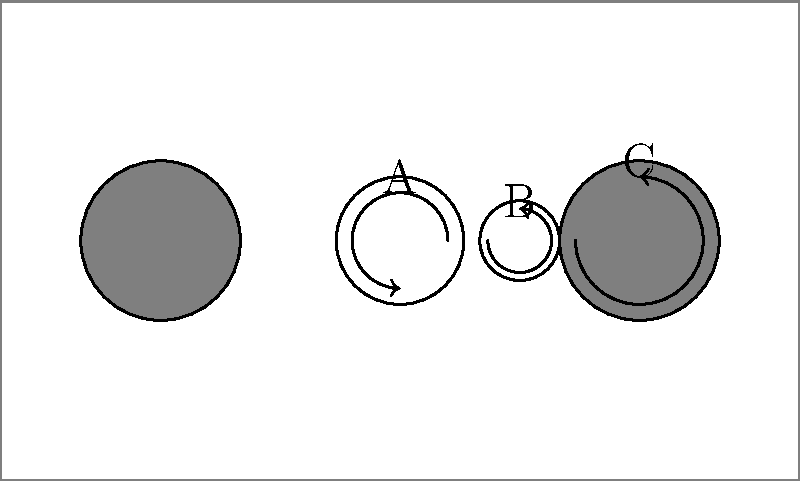In a manual film camera, gear A (radius 0.8 cm) is connected to the film advance lever. It meshes with gear B (radius 0.5 cm), which is attached to the take-up spool C (radius 1 cm). If the film advance lever rotates gear A by 270°, how many centimeters of film are wound onto the take-up spool? Let's approach this step-by-step:

1) First, we need to find how much gear B rotates when gear A rotates 270°.
   The rotation ratio is inversely proportional to the gear radii:
   $\frac{\text{Rotation of B}}{\text{Rotation of A}} = \frac{\text{Radius of A}}{\text{Radius of B}}$

2) So, $\text{Rotation of B} = 270° \times \frac{0.8 \text{ cm}}{0.5 \text{ cm}} = 432°$

3) Now, we need to find how much the take-up spool C rotates.
   Since B and C are attached, they rotate the same amount: 432°

4) To find the length of film wound, we need to calculate the arc length on the circumference of C:
   $\text{Arc length} = \text{Radius} \times \text{Angle in radians}$

5) First, convert 432° to radians:
   $432° \times \frac{\pi}{180°} = 2.4\pi \text{ radians}$

6) Now calculate the arc length:
   $\text{Arc length} = 1 \text{ cm} \times 2.4\pi \text{ radians} = 2.4\pi \text{ cm}$

Therefore, $2.4\pi$ cm (approximately 7.54 cm) of film are wound onto the take-up spool.
Answer: $2.4\pi$ cm 